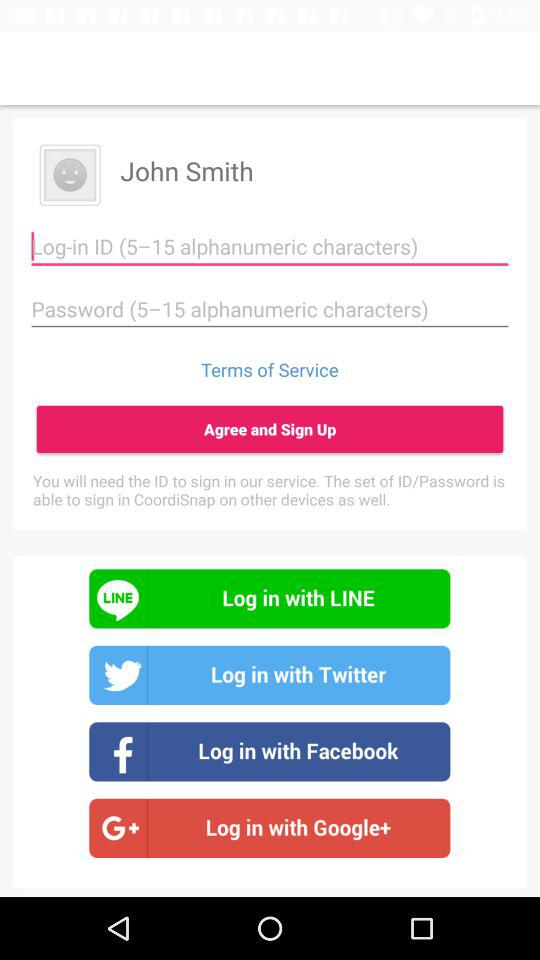What is the user name? The user name is John Smith. 